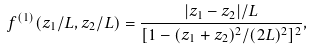Convert formula to latex. <formula><loc_0><loc_0><loc_500><loc_500>f ^ { ( 1 ) } ( z _ { 1 } / L , z _ { 2 } / L ) = \frac { | z _ { 1 } - z _ { 2 } | / L } { [ 1 - ( z _ { 1 } + z _ { 2 } ) ^ { 2 } / ( 2 L ) ^ { 2 } ] ^ { 2 } } ,</formula> 